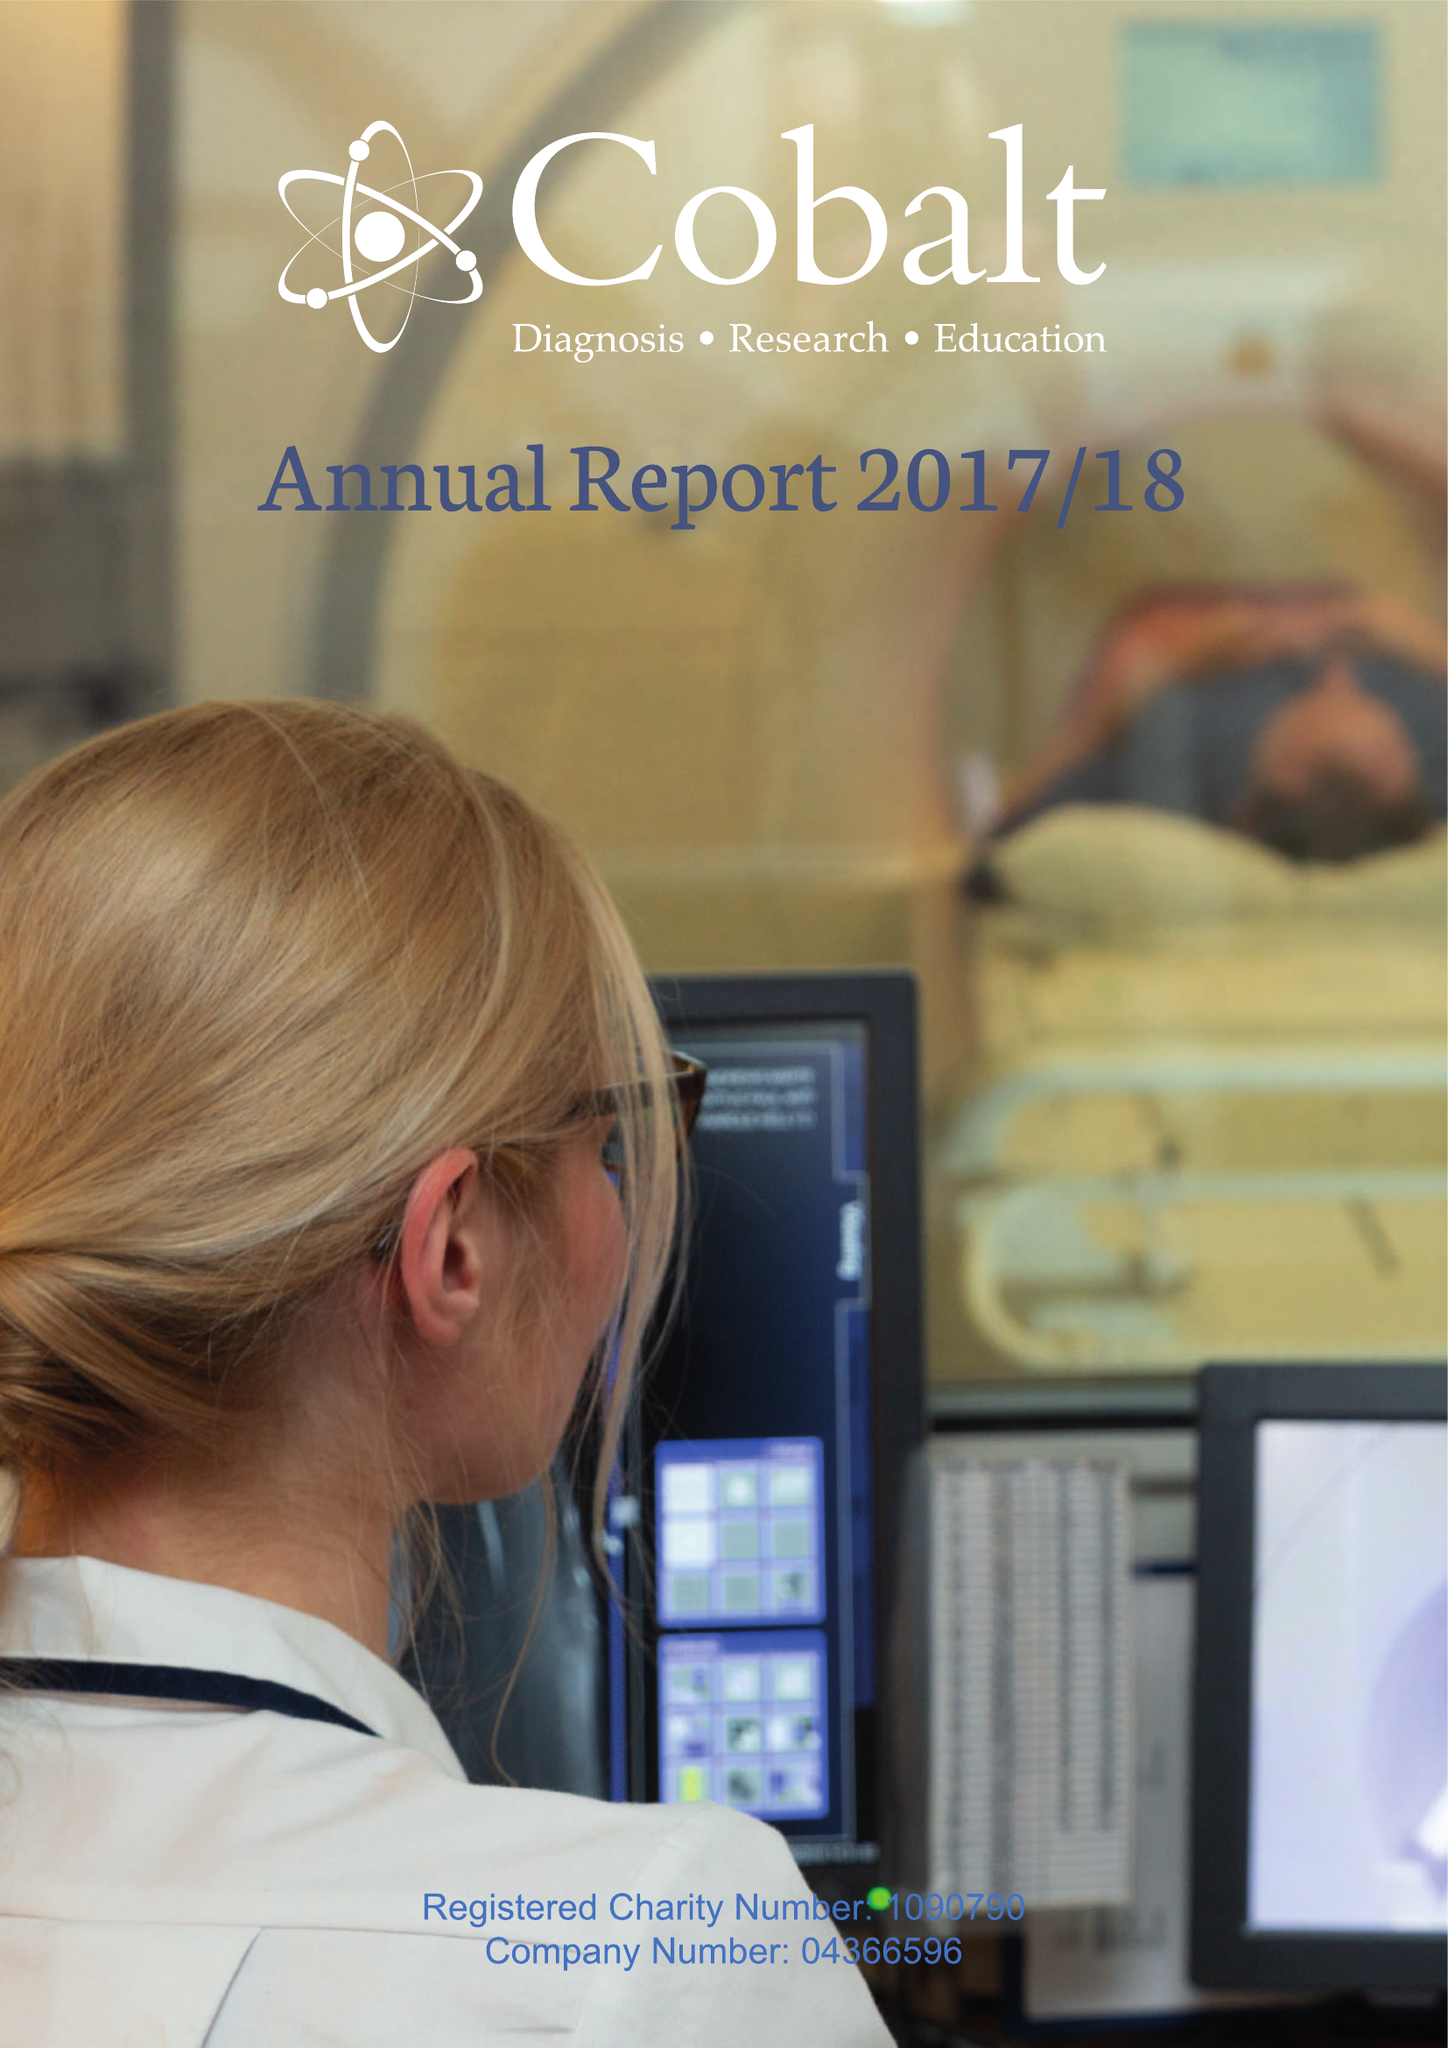What is the value for the charity_number?
Answer the question using a single word or phrase. 1090790 